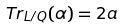Convert formula to latex. <formula><loc_0><loc_0><loc_500><loc_500>T r _ { L / Q } ( \alpha ) = 2 a</formula> 